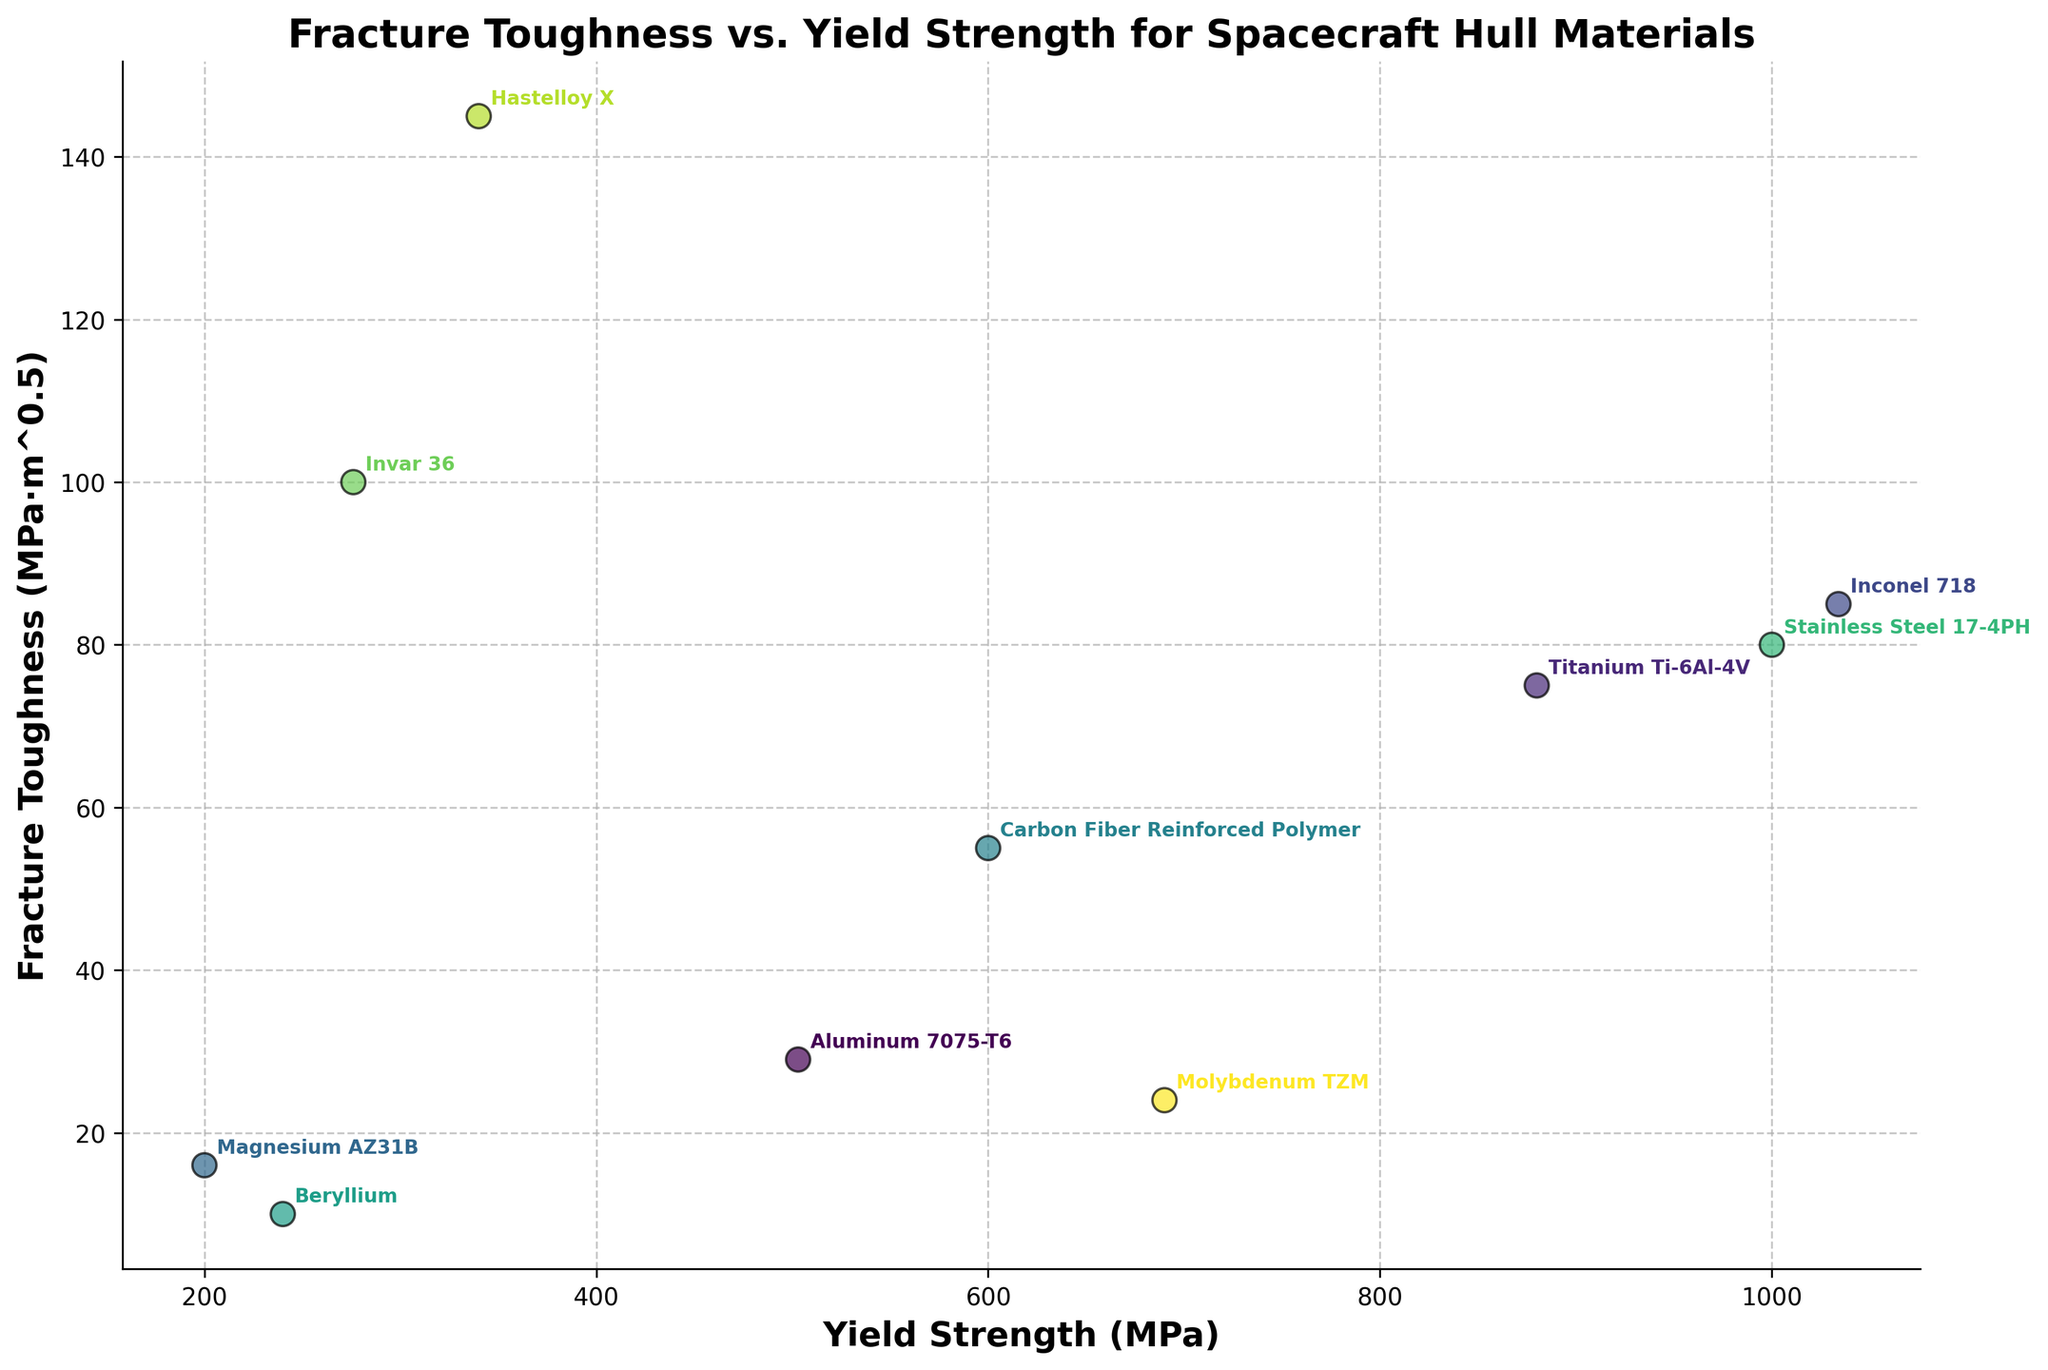Which material has the highest yield strength? By examining the x-axis, which represents yield strength, locate the data point furthest to the right. This corresponds to Inconel 718.
Answer: Inconel 718 Which materials have a fracture toughness greater than 80 MPa·m^0.5? Look along the y-axis for fracture toughness values above 80. The materials that meet this criteria are Inconel 718, Stainless Steel 17-4PH, Invar 36, and Hastelloy X.
Answer: Inconel 718, Stainless Steel 17-4PH, Invar 36, Hastelloy X Which material exhibits both high yield strength and high fracture toughness? Identify the material that appears in the upper right quadrant of the biplot, combining high values on both the x-axis (yield strength) and y-axis (fracture toughness). This corresponds to Inconel 718.
Answer: Inconel 718 What is the range of yield strength values in the plot? Determine the minimum and maximum yield strength values by observing the extreme points on the x-axis. The minimum yield strength is 200 MPa (Magnesium AZ31B) and the maximum is 1034 MPa (Inconel 718). The range is 1034 - 200.
Answer: 834 MPa Compare the fracture toughness of Aluminum 7075-T6 to Titanium Ti-6Al-4V. Which material is more resistant to fracture? Locate both materials on the biplot and compare their y-axis values. Aluminum 7075-T6 has a fracture toughness of 29 MPa·m^0.5, while Titanium Ti-6Al-4V has 75 MPa·m^0.5. Therefore, Titanium Ti-6Al-4V is more resistant.
Answer: Titanium Ti-6Al-4V What is the average fracture toughness of all materials displayed? Sum the fracture toughness values for all materials (29 + 75 + 85 + 16 + 55 + 10 + 80 + 100 + 145 + 24) = 619. Divide by the number of materials, which is 10. The average is 619 / 10.
Answer: 61.9 MPa·m^0.5 List the materials that have yield strengths less than 300 MPa. Look at the x-axis for points to the left of the 300 MPa mark. The materials are Magnesium AZ31B and Invar 36.
Answer: Magnesium AZ31B, Invar 36 Which material has the lowest fracture toughness? Find the data point with the lowest position on the y-axis. This corresponds to Beryllium.
Answer: Beryllium Compare the yield strength of Carbon Fiber Reinforced Polymer and Molybdenum TZM. Which is higher? Locate both materials on the biplot and compare their x-axis values. Carbon Fiber Reinforced Polymer has a yield strength of 600 MPa, while Molybdenum TZM has 690 MPa. Therefore, Molybdenum TZM is higher.
Answer: Molybdenum TZM Identify the material that has the highest combination of yield strength and fracture toughness. By simultaneously looking at the highest values along both x and y axes, focus on the top right region of the biplot. Hastelloy X stands out with high values in both dimensions.
Answer: Hastelloy X 